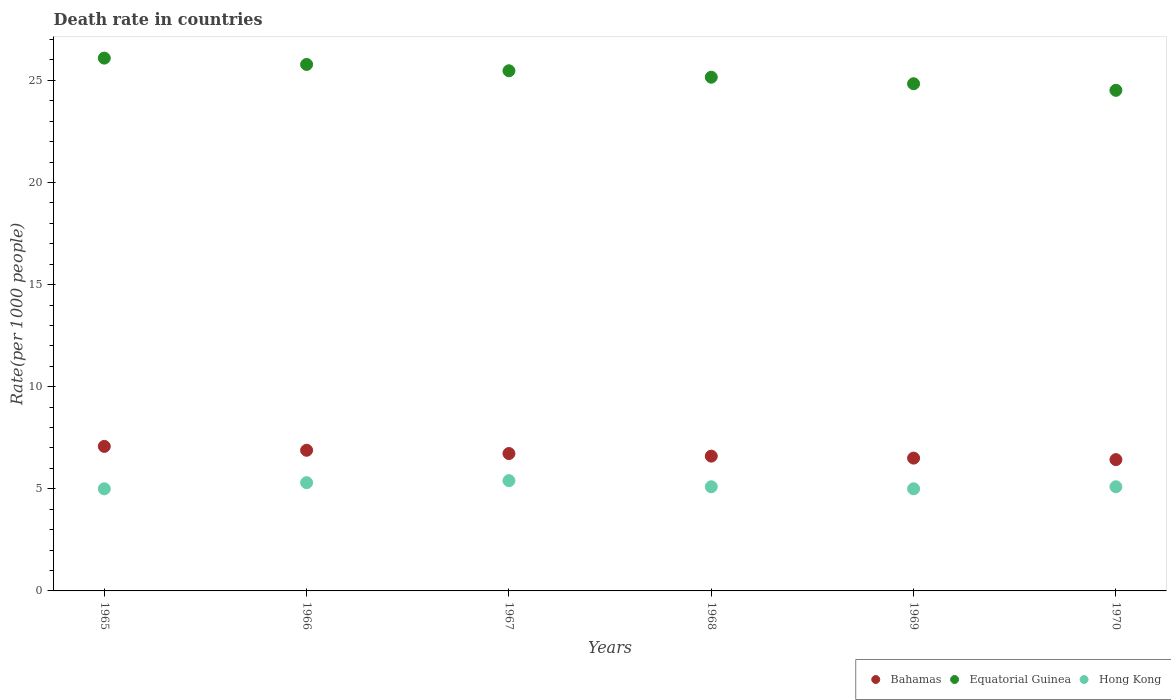How many different coloured dotlines are there?
Provide a short and direct response. 3. Is the number of dotlines equal to the number of legend labels?
Your answer should be compact. Yes. What is the death rate in Hong Kong in 1969?
Keep it short and to the point. 5. Across all years, what is the maximum death rate in Equatorial Guinea?
Provide a short and direct response. 26.09. Across all years, what is the minimum death rate in Equatorial Guinea?
Provide a succinct answer. 24.51. In which year was the death rate in Hong Kong maximum?
Give a very brief answer. 1967. What is the total death rate in Equatorial Guinea in the graph?
Provide a short and direct response. 151.84. What is the difference between the death rate in Bahamas in 1966 and that in 1969?
Keep it short and to the point. 0.38. What is the difference between the death rate in Bahamas in 1970 and the death rate in Hong Kong in 1968?
Provide a succinct answer. 1.33. What is the average death rate in Hong Kong per year?
Offer a very short reply. 5.15. In the year 1966, what is the difference between the death rate in Hong Kong and death rate in Equatorial Guinea?
Your answer should be compact. -20.48. In how many years, is the death rate in Equatorial Guinea greater than 25?
Your response must be concise. 4. What is the ratio of the death rate in Bahamas in 1967 to that in 1968?
Offer a very short reply. 1.02. Is the death rate in Hong Kong in 1966 less than that in 1969?
Give a very brief answer. No. Is the difference between the death rate in Hong Kong in 1967 and 1970 greater than the difference between the death rate in Equatorial Guinea in 1967 and 1970?
Your answer should be compact. No. What is the difference between the highest and the second highest death rate in Equatorial Guinea?
Your response must be concise. 0.31. What is the difference between the highest and the lowest death rate in Equatorial Guinea?
Keep it short and to the point. 1.58. In how many years, is the death rate in Hong Kong greater than the average death rate in Hong Kong taken over all years?
Give a very brief answer. 2. Is the sum of the death rate in Hong Kong in 1966 and 1969 greater than the maximum death rate in Equatorial Guinea across all years?
Offer a terse response. No. Is it the case that in every year, the sum of the death rate in Bahamas and death rate in Hong Kong  is greater than the death rate in Equatorial Guinea?
Give a very brief answer. No. Is the death rate in Bahamas strictly less than the death rate in Hong Kong over the years?
Your response must be concise. No. How many dotlines are there?
Your answer should be very brief. 3. Are the values on the major ticks of Y-axis written in scientific E-notation?
Provide a short and direct response. No. Does the graph contain grids?
Your answer should be compact. No. Where does the legend appear in the graph?
Ensure brevity in your answer.  Bottom right. What is the title of the graph?
Keep it short and to the point. Death rate in countries. Does "Cabo Verde" appear as one of the legend labels in the graph?
Provide a succinct answer. No. What is the label or title of the Y-axis?
Your answer should be compact. Rate(per 1000 people). What is the Rate(per 1000 people) of Bahamas in 1965?
Ensure brevity in your answer.  7.08. What is the Rate(per 1000 people) in Equatorial Guinea in 1965?
Provide a succinct answer. 26.09. What is the Rate(per 1000 people) of Hong Kong in 1965?
Provide a short and direct response. 5. What is the Rate(per 1000 people) in Bahamas in 1966?
Give a very brief answer. 6.89. What is the Rate(per 1000 people) in Equatorial Guinea in 1966?
Make the answer very short. 25.78. What is the Rate(per 1000 people) of Bahamas in 1967?
Give a very brief answer. 6.73. What is the Rate(per 1000 people) in Equatorial Guinea in 1967?
Offer a terse response. 25.47. What is the Rate(per 1000 people) of Bahamas in 1968?
Provide a short and direct response. 6.6. What is the Rate(per 1000 people) of Equatorial Guinea in 1968?
Keep it short and to the point. 25.15. What is the Rate(per 1000 people) in Bahamas in 1969?
Your answer should be very brief. 6.5. What is the Rate(per 1000 people) in Equatorial Guinea in 1969?
Ensure brevity in your answer.  24.83. What is the Rate(per 1000 people) of Hong Kong in 1969?
Give a very brief answer. 5. What is the Rate(per 1000 people) in Bahamas in 1970?
Your answer should be very brief. 6.43. What is the Rate(per 1000 people) in Equatorial Guinea in 1970?
Provide a short and direct response. 24.51. Across all years, what is the maximum Rate(per 1000 people) of Bahamas?
Provide a short and direct response. 7.08. Across all years, what is the maximum Rate(per 1000 people) of Equatorial Guinea?
Ensure brevity in your answer.  26.09. Across all years, what is the maximum Rate(per 1000 people) in Hong Kong?
Make the answer very short. 5.4. Across all years, what is the minimum Rate(per 1000 people) of Bahamas?
Give a very brief answer. 6.43. Across all years, what is the minimum Rate(per 1000 people) in Equatorial Guinea?
Provide a succinct answer. 24.51. What is the total Rate(per 1000 people) in Bahamas in the graph?
Provide a succinct answer. 40.22. What is the total Rate(per 1000 people) of Equatorial Guinea in the graph?
Provide a short and direct response. 151.84. What is the total Rate(per 1000 people) in Hong Kong in the graph?
Make the answer very short. 30.9. What is the difference between the Rate(per 1000 people) in Bahamas in 1965 and that in 1966?
Offer a very short reply. 0.19. What is the difference between the Rate(per 1000 people) of Equatorial Guinea in 1965 and that in 1966?
Your answer should be compact. 0.31. What is the difference between the Rate(per 1000 people) in Equatorial Guinea in 1965 and that in 1967?
Keep it short and to the point. 0.62. What is the difference between the Rate(per 1000 people) in Hong Kong in 1965 and that in 1967?
Offer a very short reply. -0.4. What is the difference between the Rate(per 1000 people) of Bahamas in 1965 and that in 1968?
Your answer should be very brief. 0.48. What is the difference between the Rate(per 1000 people) of Equatorial Guinea in 1965 and that in 1968?
Keep it short and to the point. 0.94. What is the difference between the Rate(per 1000 people) of Hong Kong in 1965 and that in 1968?
Offer a very short reply. -0.1. What is the difference between the Rate(per 1000 people) in Bahamas in 1965 and that in 1969?
Your response must be concise. 0.57. What is the difference between the Rate(per 1000 people) of Equatorial Guinea in 1965 and that in 1969?
Make the answer very short. 1.25. What is the difference between the Rate(per 1000 people) in Bahamas in 1965 and that in 1970?
Your answer should be compact. 0.65. What is the difference between the Rate(per 1000 people) of Equatorial Guinea in 1965 and that in 1970?
Your answer should be compact. 1.58. What is the difference between the Rate(per 1000 people) of Bahamas in 1966 and that in 1967?
Offer a very short reply. 0.16. What is the difference between the Rate(per 1000 people) of Equatorial Guinea in 1966 and that in 1967?
Give a very brief answer. 0.31. What is the difference between the Rate(per 1000 people) of Bahamas in 1966 and that in 1968?
Keep it short and to the point. 0.29. What is the difference between the Rate(per 1000 people) in Hong Kong in 1966 and that in 1968?
Provide a succinct answer. 0.2. What is the difference between the Rate(per 1000 people) of Bahamas in 1966 and that in 1969?
Make the answer very short. 0.38. What is the difference between the Rate(per 1000 people) of Equatorial Guinea in 1966 and that in 1969?
Make the answer very short. 0.94. What is the difference between the Rate(per 1000 people) in Hong Kong in 1966 and that in 1969?
Offer a very short reply. 0.3. What is the difference between the Rate(per 1000 people) in Bahamas in 1966 and that in 1970?
Give a very brief answer. 0.46. What is the difference between the Rate(per 1000 people) of Equatorial Guinea in 1966 and that in 1970?
Provide a short and direct response. 1.27. What is the difference between the Rate(per 1000 people) in Bahamas in 1967 and that in 1968?
Your answer should be compact. 0.13. What is the difference between the Rate(per 1000 people) of Equatorial Guinea in 1967 and that in 1968?
Provide a succinct answer. 0.32. What is the difference between the Rate(per 1000 people) in Hong Kong in 1967 and that in 1968?
Offer a very short reply. 0.3. What is the difference between the Rate(per 1000 people) of Bahamas in 1967 and that in 1969?
Provide a succinct answer. 0.22. What is the difference between the Rate(per 1000 people) of Equatorial Guinea in 1967 and that in 1969?
Keep it short and to the point. 0.64. What is the difference between the Rate(per 1000 people) of Bahamas in 1967 and that in 1970?
Offer a terse response. 0.3. What is the difference between the Rate(per 1000 people) in Equatorial Guinea in 1967 and that in 1970?
Keep it short and to the point. 0.96. What is the difference between the Rate(per 1000 people) in Bahamas in 1968 and that in 1969?
Give a very brief answer. 0.1. What is the difference between the Rate(per 1000 people) in Equatorial Guinea in 1968 and that in 1969?
Make the answer very short. 0.32. What is the difference between the Rate(per 1000 people) in Hong Kong in 1968 and that in 1969?
Ensure brevity in your answer.  0.1. What is the difference between the Rate(per 1000 people) of Bahamas in 1968 and that in 1970?
Offer a very short reply. 0.17. What is the difference between the Rate(per 1000 people) in Equatorial Guinea in 1968 and that in 1970?
Provide a short and direct response. 0.64. What is the difference between the Rate(per 1000 people) in Hong Kong in 1968 and that in 1970?
Provide a short and direct response. 0. What is the difference between the Rate(per 1000 people) of Bahamas in 1969 and that in 1970?
Keep it short and to the point. 0.07. What is the difference between the Rate(per 1000 people) in Equatorial Guinea in 1969 and that in 1970?
Your response must be concise. 0.32. What is the difference between the Rate(per 1000 people) of Bahamas in 1965 and the Rate(per 1000 people) of Equatorial Guinea in 1966?
Offer a terse response. -18.7. What is the difference between the Rate(per 1000 people) of Bahamas in 1965 and the Rate(per 1000 people) of Hong Kong in 1966?
Provide a succinct answer. 1.78. What is the difference between the Rate(per 1000 people) of Equatorial Guinea in 1965 and the Rate(per 1000 people) of Hong Kong in 1966?
Provide a short and direct response. 20.79. What is the difference between the Rate(per 1000 people) in Bahamas in 1965 and the Rate(per 1000 people) in Equatorial Guinea in 1967?
Offer a terse response. -18.39. What is the difference between the Rate(per 1000 people) of Bahamas in 1965 and the Rate(per 1000 people) of Hong Kong in 1967?
Offer a terse response. 1.68. What is the difference between the Rate(per 1000 people) of Equatorial Guinea in 1965 and the Rate(per 1000 people) of Hong Kong in 1967?
Offer a very short reply. 20.69. What is the difference between the Rate(per 1000 people) in Bahamas in 1965 and the Rate(per 1000 people) in Equatorial Guinea in 1968?
Provide a succinct answer. -18.08. What is the difference between the Rate(per 1000 people) in Bahamas in 1965 and the Rate(per 1000 people) in Hong Kong in 1968?
Provide a short and direct response. 1.98. What is the difference between the Rate(per 1000 people) in Equatorial Guinea in 1965 and the Rate(per 1000 people) in Hong Kong in 1968?
Your answer should be compact. 20.99. What is the difference between the Rate(per 1000 people) of Bahamas in 1965 and the Rate(per 1000 people) of Equatorial Guinea in 1969?
Provide a succinct answer. -17.76. What is the difference between the Rate(per 1000 people) of Bahamas in 1965 and the Rate(per 1000 people) of Hong Kong in 1969?
Provide a short and direct response. 2.08. What is the difference between the Rate(per 1000 people) in Equatorial Guinea in 1965 and the Rate(per 1000 people) in Hong Kong in 1969?
Provide a succinct answer. 21.09. What is the difference between the Rate(per 1000 people) of Bahamas in 1965 and the Rate(per 1000 people) of Equatorial Guinea in 1970?
Your answer should be compact. -17.43. What is the difference between the Rate(per 1000 people) of Bahamas in 1965 and the Rate(per 1000 people) of Hong Kong in 1970?
Your answer should be very brief. 1.98. What is the difference between the Rate(per 1000 people) in Equatorial Guinea in 1965 and the Rate(per 1000 people) in Hong Kong in 1970?
Offer a terse response. 20.99. What is the difference between the Rate(per 1000 people) in Bahamas in 1966 and the Rate(per 1000 people) in Equatorial Guinea in 1967?
Offer a very short reply. -18.58. What is the difference between the Rate(per 1000 people) in Bahamas in 1966 and the Rate(per 1000 people) in Hong Kong in 1967?
Offer a terse response. 1.49. What is the difference between the Rate(per 1000 people) in Equatorial Guinea in 1966 and the Rate(per 1000 people) in Hong Kong in 1967?
Your response must be concise. 20.38. What is the difference between the Rate(per 1000 people) in Bahamas in 1966 and the Rate(per 1000 people) in Equatorial Guinea in 1968?
Your answer should be compact. -18.27. What is the difference between the Rate(per 1000 people) of Bahamas in 1966 and the Rate(per 1000 people) of Hong Kong in 1968?
Ensure brevity in your answer.  1.79. What is the difference between the Rate(per 1000 people) in Equatorial Guinea in 1966 and the Rate(per 1000 people) in Hong Kong in 1968?
Provide a succinct answer. 20.68. What is the difference between the Rate(per 1000 people) of Bahamas in 1966 and the Rate(per 1000 people) of Equatorial Guinea in 1969?
Keep it short and to the point. -17.95. What is the difference between the Rate(per 1000 people) of Bahamas in 1966 and the Rate(per 1000 people) of Hong Kong in 1969?
Ensure brevity in your answer.  1.89. What is the difference between the Rate(per 1000 people) of Equatorial Guinea in 1966 and the Rate(per 1000 people) of Hong Kong in 1969?
Give a very brief answer. 20.78. What is the difference between the Rate(per 1000 people) in Bahamas in 1966 and the Rate(per 1000 people) in Equatorial Guinea in 1970?
Your response must be concise. -17.62. What is the difference between the Rate(per 1000 people) of Bahamas in 1966 and the Rate(per 1000 people) of Hong Kong in 1970?
Your response must be concise. 1.79. What is the difference between the Rate(per 1000 people) of Equatorial Guinea in 1966 and the Rate(per 1000 people) of Hong Kong in 1970?
Your response must be concise. 20.68. What is the difference between the Rate(per 1000 people) of Bahamas in 1967 and the Rate(per 1000 people) of Equatorial Guinea in 1968?
Your answer should be compact. -18.43. What is the difference between the Rate(per 1000 people) in Bahamas in 1967 and the Rate(per 1000 people) in Hong Kong in 1968?
Your response must be concise. 1.63. What is the difference between the Rate(per 1000 people) of Equatorial Guinea in 1967 and the Rate(per 1000 people) of Hong Kong in 1968?
Offer a very short reply. 20.37. What is the difference between the Rate(per 1000 people) of Bahamas in 1967 and the Rate(per 1000 people) of Equatorial Guinea in 1969?
Ensure brevity in your answer.  -18.11. What is the difference between the Rate(per 1000 people) of Bahamas in 1967 and the Rate(per 1000 people) of Hong Kong in 1969?
Offer a very short reply. 1.73. What is the difference between the Rate(per 1000 people) of Equatorial Guinea in 1967 and the Rate(per 1000 people) of Hong Kong in 1969?
Your answer should be very brief. 20.47. What is the difference between the Rate(per 1000 people) in Bahamas in 1967 and the Rate(per 1000 people) in Equatorial Guinea in 1970?
Ensure brevity in your answer.  -17.79. What is the difference between the Rate(per 1000 people) of Bahamas in 1967 and the Rate(per 1000 people) of Hong Kong in 1970?
Offer a very short reply. 1.63. What is the difference between the Rate(per 1000 people) in Equatorial Guinea in 1967 and the Rate(per 1000 people) in Hong Kong in 1970?
Offer a terse response. 20.37. What is the difference between the Rate(per 1000 people) of Bahamas in 1968 and the Rate(per 1000 people) of Equatorial Guinea in 1969?
Your answer should be compact. -18.23. What is the difference between the Rate(per 1000 people) in Bahamas in 1968 and the Rate(per 1000 people) in Hong Kong in 1969?
Your answer should be very brief. 1.6. What is the difference between the Rate(per 1000 people) in Equatorial Guinea in 1968 and the Rate(per 1000 people) in Hong Kong in 1969?
Your response must be concise. 20.15. What is the difference between the Rate(per 1000 people) in Bahamas in 1968 and the Rate(per 1000 people) in Equatorial Guinea in 1970?
Offer a very short reply. -17.91. What is the difference between the Rate(per 1000 people) of Bahamas in 1968 and the Rate(per 1000 people) of Hong Kong in 1970?
Offer a terse response. 1.5. What is the difference between the Rate(per 1000 people) of Equatorial Guinea in 1968 and the Rate(per 1000 people) of Hong Kong in 1970?
Ensure brevity in your answer.  20.05. What is the difference between the Rate(per 1000 people) in Bahamas in 1969 and the Rate(per 1000 people) in Equatorial Guinea in 1970?
Keep it short and to the point. -18.01. What is the difference between the Rate(per 1000 people) in Bahamas in 1969 and the Rate(per 1000 people) in Hong Kong in 1970?
Your answer should be very brief. 1.4. What is the difference between the Rate(per 1000 people) in Equatorial Guinea in 1969 and the Rate(per 1000 people) in Hong Kong in 1970?
Your answer should be very brief. 19.73. What is the average Rate(per 1000 people) in Bahamas per year?
Your answer should be very brief. 6.7. What is the average Rate(per 1000 people) in Equatorial Guinea per year?
Offer a very short reply. 25.31. What is the average Rate(per 1000 people) in Hong Kong per year?
Your response must be concise. 5.15. In the year 1965, what is the difference between the Rate(per 1000 people) of Bahamas and Rate(per 1000 people) of Equatorial Guinea?
Your answer should be compact. -19.01. In the year 1965, what is the difference between the Rate(per 1000 people) of Bahamas and Rate(per 1000 people) of Hong Kong?
Provide a short and direct response. 2.08. In the year 1965, what is the difference between the Rate(per 1000 people) of Equatorial Guinea and Rate(per 1000 people) of Hong Kong?
Give a very brief answer. 21.09. In the year 1966, what is the difference between the Rate(per 1000 people) of Bahamas and Rate(per 1000 people) of Equatorial Guinea?
Make the answer very short. -18.89. In the year 1966, what is the difference between the Rate(per 1000 people) of Bahamas and Rate(per 1000 people) of Hong Kong?
Provide a succinct answer. 1.59. In the year 1966, what is the difference between the Rate(per 1000 people) of Equatorial Guinea and Rate(per 1000 people) of Hong Kong?
Provide a short and direct response. 20.48. In the year 1967, what is the difference between the Rate(per 1000 people) in Bahamas and Rate(per 1000 people) in Equatorial Guinea?
Your response must be concise. -18.74. In the year 1967, what is the difference between the Rate(per 1000 people) of Bahamas and Rate(per 1000 people) of Hong Kong?
Give a very brief answer. 1.33. In the year 1967, what is the difference between the Rate(per 1000 people) in Equatorial Guinea and Rate(per 1000 people) in Hong Kong?
Provide a short and direct response. 20.07. In the year 1968, what is the difference between the Rate(per 1000 people) in Bahamas and Rate(per 1000 people) in Equatorial Guinea?
Make the answer very short. -18.55. In the year 1968, what is the difference between the Rate(per 1000 people) in Bahamas and Rate(per 1000 people) in Hong Kong?
Provide a succinct answer. 1.5. In the year 1968, what is the difference between the Rate(per 1000 people) in Equatorial Guinea and Rate(per 1000 people) in Hong Kong?
Offer a very short reply. 20.05. In the year 1969, what is the difference between the Rate(per 1000 people) in Bahamas and Rate(per 1000 people) in Equatorial Guinea?
Provide a succinct answer. -18.33. In the year 1969, what is the difference between the Rate(per 1000 people) in Bahamas and Rate(per 1000 people) in Hong Kong?
Your answer should be compact. 1.5. In the year 1969, what is the difference between the Rate(per 1000 people) of Equatorial Guinea and Rate(per 1000 people) of Hong Kong?
Provide a short and direct response. 19.83. In the year 1970, what is the difference between the Rate(per 1000 people) of Bahamas and Rate(per 1000 people) of Equatorial Guinea?
Offer a terse response. -18.08. In the year 1970, what is the difference between the Rate(per 1000 people) in Bahamas and Rate(per 1000 people) in Hong Kong?
Offer a terse response. 1.33. In the year 1970, what is the difference between the Rate(per 1000 people) of Equatorial Guinea and Rate(per 1000 people) of Hong Kong?
Offer a terse response. 19.41. What is the ratio of the Rate(per 1000 people) of Bahamas in 1965 to that in 1966?
Offer a terse response. 1.03. What is the ratio of the Rate(per 1000 people) of Equatorial Guinea in 1965 to that in 1966?
Keep it short and to the point. 1.01. What is the ratio of the Rate(per 1000 people) in Hong Kong in 1965 to that in 1966?
Make the answer very short. 0.94. What is the ratio of the Rate(per 1000 people) of Bahamas in 1965 to that in 1967?
Your answer should be compact. 1.05. What is the ratio of the Rate(per 1000 people) of Equatorial Guinea in 1965 to that in 1967?
Offer a very short reply. 1.02. What is the ratio of the Rate(per 1000 people) of Hong Kong in 1965 to that in 1967?
Keep it short and to the point. 0.93. What is the ratio of the Rate(per 1000 people) of Bahamas in 1965 to that in 1968?
Offer a very short reply. 1.07. What is the ratio of the Rate(per 1000 people) of Equatorial Guinea in 1965 to that in 1968?
Your answer should be compact. 1.04. What is the ratio of the Rate(per 1000 people) in Hong Kong in 1965 to that in 1968?
Ensure brevity in your answer.  0.98. What is the ratio of the Rate(per 1000 people) in Bahamas in 1965 to that in 1969?
Provide a succinct answer. 1.09. What is the ratio of the Rate(per 1000 people) in Equatorial Guinea in 1965 to that in 1969?
Offer a very short reply. 1.05. What is the ratio of the Rate(per 1000 people) in Hong Kong in 1965 to that in 1969?
Ensure brevity in your answer.  1. What is the ratio of the Rate(per 1000 people) in Bahamas in 1965 to that in 1970?
Keep it short and to the point. 1.1. What is the ratio of the Rate(per 1000 people) of Equatorial Guinea in 1965 to that in 1970?
Provide a succinct answer. 1.06. What is the ratio of the Rate(per 1000 people) in Hong Kong in 1965 to that in 1970?
Give a very brief answer. 0.98. What is the ratio of the Rate(per 1000 people) in Bahamas in 1966 to that in 1967?
Keep it short and to the point. 1.02. What is the ratio of the Rate(per 1000 people) in Equatorial Guinea in 1966 to that in 1967?
Provide a succinct answer. 1.01. What is the ratio of the Rate(per 1000 people) in Hong Kong in 1966 to that in 1967?
Offer a very short reply. 0.98. What is the ratio of the Rate(per 1000 people) of Bahamas in 1966 to that in 1968?
Make the answer very short. 1.04. What is the ratio of the Rate(per 1000 people) of Equatorial Guinea in 1966 to that in 1968?
Your answer should be very brief. 1.02. What is the ratio of the Rate(per 1000 people) of Hong Kong in 1966 to that in 1968?
Make the answer very short. 1.04. What is the ratio of the Rate(per 1000 people) in Bahamas in 1966 to that in 1969?
Keep it short and to the point. 1.06. What is the ratio of the Rate(per 1000 people) of Equatorial Guinea in 1966 to that in 1969?
Your answer should be very brief. 1.04. What is the ratio of the Rate(per 1000 people) of Hong Kong in 1966 to that in 1969?
Provide a short and direct response. 1.06. What is the ratio of the Rate(per 1000 people) of Bahamas in 1966 to that in 1970?
Provide a short and direct response. 1.07. What is the ratio of the Rate(per 1000 people) in Equatorial Guinea in 1966 to that in 1970?
Your response must be concise. 1.05. What is the ratio of the Rate(per 1000 people) in Hong Kong in 1966 to that in 1970?
Your answer should be compact. 1.04. What is the ratio of the Rate(per 1000 people) in Bahamas in 1967 to that in 1968?
Ensure brevity in your answer.  1.02. What is the ratio of the Rate(per 1000 people) of Equatorial Guinea in 1967 to that in 1968?
Offer a very short reply. 1.01. What is the ratio of the Rate(per 1000 people) of Hong Kong in 1967 to that in 1968?
Your response must be concise. 1.06. What is the ratio of the Rate(per 1000 people) of Bahamas in 1967 to that in 1969?
Ensure brevity in your answer.  1.03. What is the ratio of the Rate(per 1000 people) in Equatorial Guinea in 1967 to that in 1969?
Provide a succinct answer. 1.03. What is the ratio of the Rate(per 1000 people) in Bahamas in 1967 to that in 1970?
Your answer should be very brief. 1.05. What is the ratio of the Rate(per 1000 people) in Equatorial Guinea in 1967 to that in 1970?
Provide a succinct answer. 1.04. What is the ratio of the Rate(per 1000 people) of Hong Kong in 1967 to that in 1970?
Ensure brevity in your answer.  1.06. What is the ratio of the Rate(per 1000 people) in Bahamas in 1968 to that in 1969?
Provide a short and direct response. 1.01. What is the ratio of the Rate(per 1000 people) of Equatorial Guinea in 1968 to that in 1969?
Ensure brevity in your answer.  1.01. What is the ratio of the Rate(per 1000 people) in Hong Kong in 1968 to that in 1969?
Give a very brief answer. 1.02. What is the ratio of the Rate(per 1000 people) in Bahamas in 1968 to that in 1970?
Provide a succinct answer. 1.03. What is the ratio of the Rate(per 1000 people) in Equatorial Guinea in 1968 to that in 1970?
Keep it short and to the point. 1.03. What is the ratio of the Rate(per 1000 people) of Bahamas in 1969 to that in 1970?
Ensure brevity in your answer.  1.01. What is the ratio of the Rate(per 1000 people) of Equatorial Guinea in 1969 to that in 1970?
Your answer should be very brief. 1.01. What is the ratio of the Rate(per 1000 people) of Hong Kong in 1969 to that in 1970?
Ensure brevity in your answer.  0.98. What is the difference between the highest and the second highest Rate(per 1000 people) of Bahamas?
Your answer should be compact. 0.19. What is the difference between the highest and the second highest Rate(per 1000 people) of Equatorial Guinea?
Ensure brevity in your answer.  0.31. What is the difference between the highest and the lowest Rate(per 1000 people) of Bahamas?
Make the answer very short. 0.65. What is the difference between the highest and the lowest Rate(per 1000 people) in Equatorial Guinea?
Ensure brevity in your answer.  1.58. What is the difference between the highest and the lowest Rate(per 1000 people) in Hong Kong?
Provide a short and direct response. 0.4. 